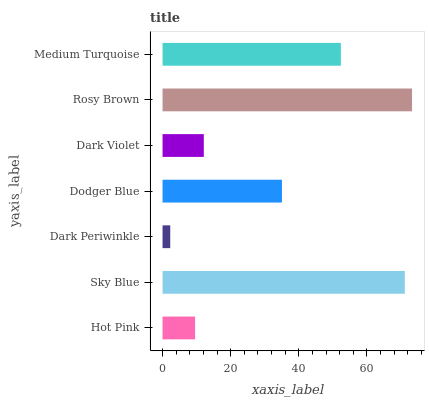Is Dark Periwinkle the minimum?
Answer yes or no. Yes. Is Rosy Brown the maximum?
Answer yes or no. Yes. Is Sky Blue the minimum?
Answer yes or no. No. Is Sky Blue the maximum?
Answer yes or no. No. Is Sky Blue greater than Hot Pink?
Answer yes or no. Yes. Is Hot Pink less than Sky Blue?
Answer yes or no. Yes. Is Hot Pink greater than Sky Blue?
Answer yes or no. No. Is Sky Blue less than Hot Pink?
Answer yes or no. No. Is Dodger Blue the high median?
Answer yes or no. Yes. Is Dodger Blue the low median?
Answer yes or no. Yes. Is Sky Blue the high median?
Answer yes or no. No. Is Medium Turquoise the low median?
Answer yes or no. No. 